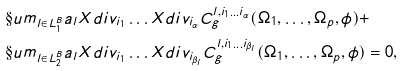Convert formula to latex. <formula><loc_0><loc_0><loc_500><loc_500>& \S u m _ { l \in L ^ { B } _ { 1 } } a _ { l } X d i v _ { i _ { 1 } } \dots X d i v _ { i _ { \alpha } } C ^ { l , i _ { 1 } \dots i _ { \alpha } } _ { g } ( \Omega _ { 1 } , \dots , \Omega _ { p } , \phi ) + \\ & \S u m _ { l \in L ^ { B } _ { 2 } } a _ { l } X d i v _ { i _ { 1 } } \dots X d i v _ { i _ { \beta _ { l } } } C ^ { l , i _ { 1 } \dots i _ { \beta _ { l } } } _ { g } ( \Omega _ { 1 } , \dots , \Omega _ { p } , \phi ) = 0 ,</formula> 